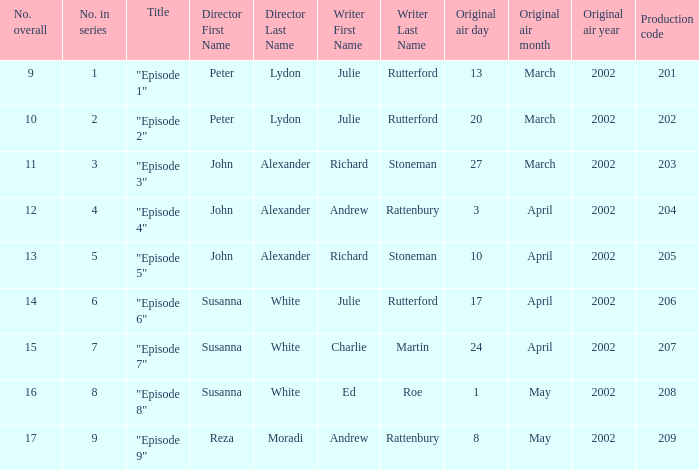When "episode 1" is the title what is the overall number? 9.0. 